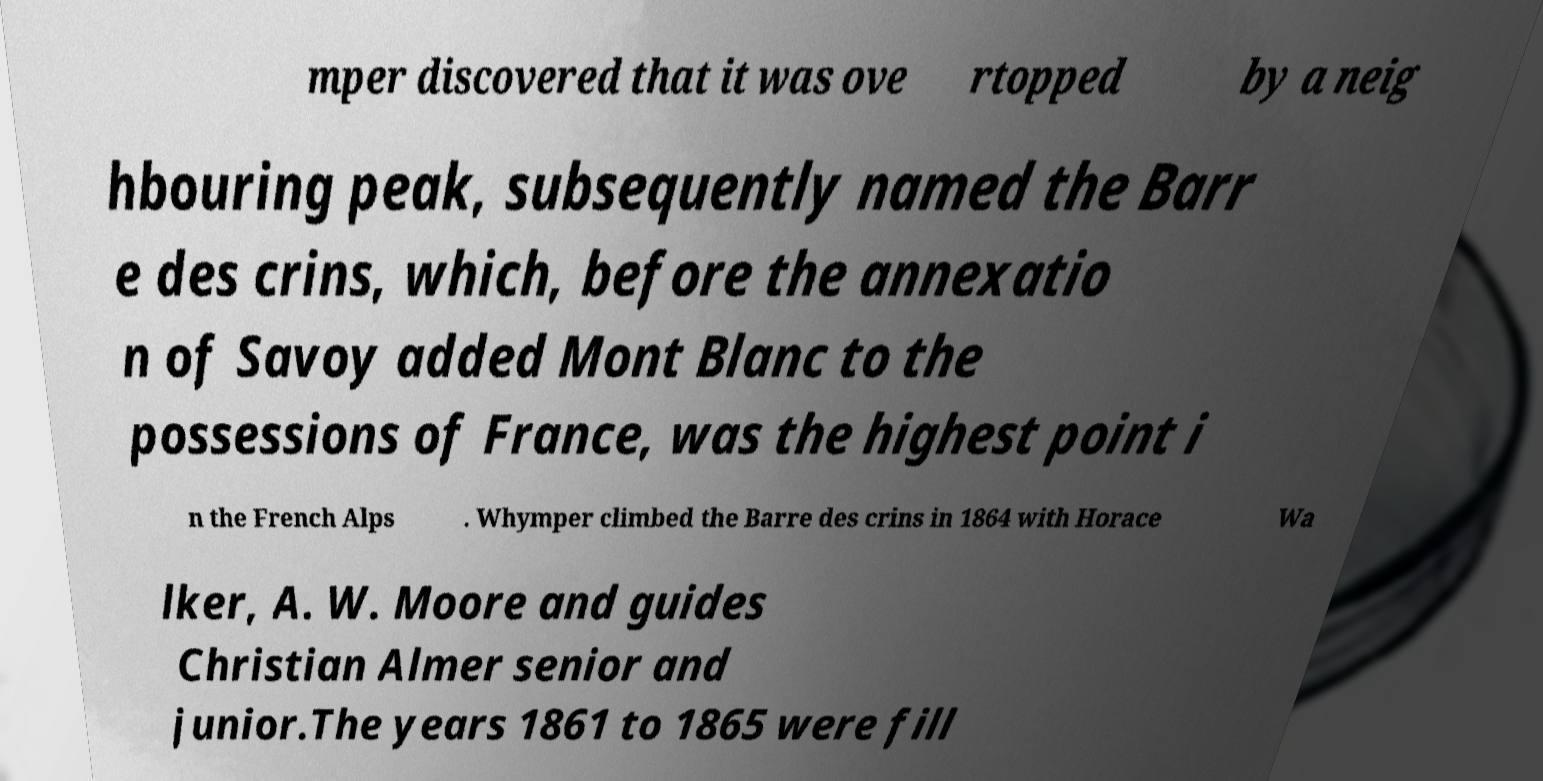Please identify and transcribe the text found in this image. mper discovered that it was ove rtopped by a neig hbouring peak, subsequently named the Barr e des crins, which, before the annexatio n of Savoy added Mont Blanc to the possessions of France, was the highest point i n the French Alps . Whymper climbed the Barre des crins in 1864 with Horace Wa lker, A. W. Moore and guides Christian Almer senior and junior.The years 1861 to 1865 were fill 